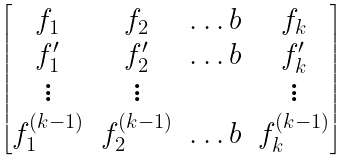<formula> <loc_0><loc_0><loc_500><loc_500>\begin{bmatrix} f _ { 1 } & f _ { 2 } & \dots b & f _ { k } \\ f _ { 1 } ^ { \prime } & f _ { 2 } ^ { \prime } & \dots b & f _ { k } ^ { \prime } \\ \vdots & \vdots & & \vdots \\ f _ { 1 } ^ { ( k - 1 ) } & f _ { 2 } ^ { ( k - 1 ) } & \dots b & f _ { k } ^ { ( k - 1 ) } \end{bmatrix}</formula> 